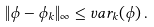<formula> <loc_0><loc_0><loc_500><loc_500>\| \phi - \phi _ { k } \| _ { \infty } \leq v a r _ { k } ( \phi ) \, .</formula> 